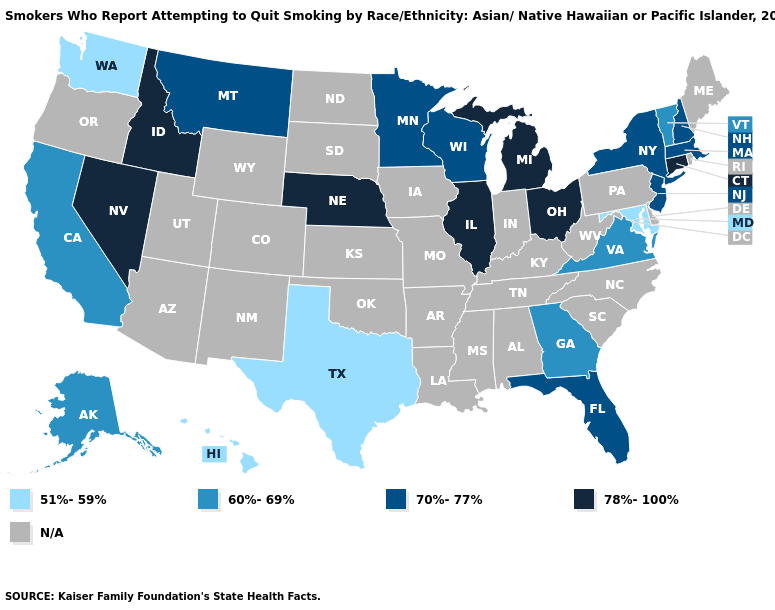What is the lowest value in states that border Iowa?
Be succinct. 70%-77%. What is the value of Rhode Island?
Quick response, please. N/A. Does the first symbol in the legend represent the smallest category?
Short answer required. Yes. Which states have the highest value in the USA?
Quick response, please. Connecticut, Idaho, Illinois, Michigan, Nebraska, Nevada, Ohio. Name the states that have a value in the range 51%-59%?
Quick response, please. Hawaii, Maryland, Texas, Washington. Does Connecticut have the highest value in the Northeast?
Concise answer only. Yes. Name the states that have a value in the range N/A?
Keep it brief. Alabama, Arizona, Arkansas, Colorado, Delaware, Indiana, Iowa, Kansas, Kentucky, Louisiana, Maine, Mississippi, Missouri, New Mexico, North Carolina, North Dakota, Oklahoma, Oregon, Pennsylvania, Rhode Island, South Carolina, South Dakota, Tennessee, Utah, West Virginia, Wyoming. Name the states that have a value in the range 70%-77%?
Concise answer only. Florida, Massachusetts, Minnesota, Montana, New Hampshire, New Jersey, New York, Wisconsin. Among the states that border Wyoming , does Montana have the lowest value?
Quick response, please. Yes. What is the highest value in the USA?
Quick response, please. 78%-100%. Name the states that have a value in the range 60%-69%?
Give a very brief answer. Alaska, California, Georgia, Vermont, Virginia. Which states have the lowest value in the USA?
Give a very brief answer. Hawaii, Maryland, Texas, Washington. Among the states that border Delaware , does New Jersey have the highest value?
Write a very short answer. Yes. 